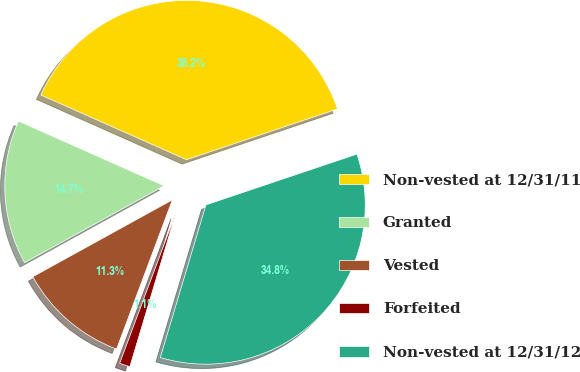Convert chart. <chart><loc_0><loc_0><loc_500><loc_500><pie_chart><fcel>Non-vested at 12/31/11<fcel>Granted<fcel>Vested<fcel>Forfeited<fcel>Non-vested at 12/31/12<nl><fcel>38.18%<fcel>14.67%<fcel>11.29%<fcel>1.07%<fcel>34.79%<nl></chart> 